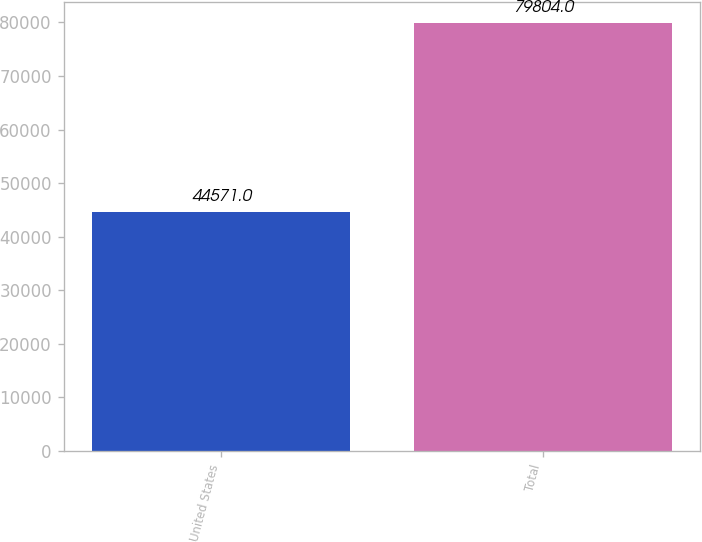Convert chart. <chart><loc_0><loc_0><loc_500><loc_500><bar_chart><fcel>United States<fcel>Total<nl><fcel>44571<fcel>79804<nl></chart> 